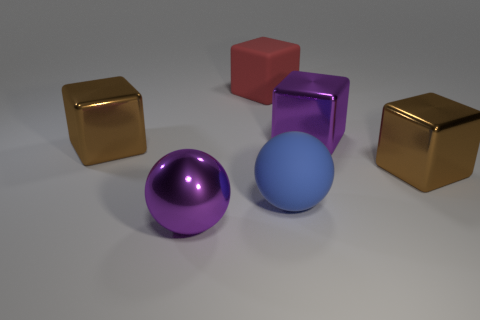What number of shiny objects have the same color as the metal sphere?
Provide a short and direct response. 1. Are there fewer blue balls than green shiny spheres?
Offer a terse response. No. Are there more brown metallic cubes that are to the right of the large blue matte sphere than brown things behind the purple metal block?
Your answer should be very brief. Yes. Is the material of the red thing the same as the big blue sphere?
Your answer should be compact. Yes. How many large shiny blocks are to the left of the large brown metallic cube that is to the right of the large purple block?
Your answer should be very brief. 2. What number of things are either shiny blocks or big brown things that are left of the large metal ball?
Your answer should be very brief. 3. There is a matte thing that is in front of the big red cube; is its shape the same as the purple object on the right side of the red matte cube?
Your response must be concise. No. Are there any other things that have the same color as the metallic sphere?
Keep it short and to the point. Yes. What is the shape of the blue object that is made of the same material as the large red thing?
Your answer should be very brief. Sphere. What is the material of the object that is both on the left side of the purple metal block and to the right of the rubber cube?
Provide a short and direct response. Rubber. 